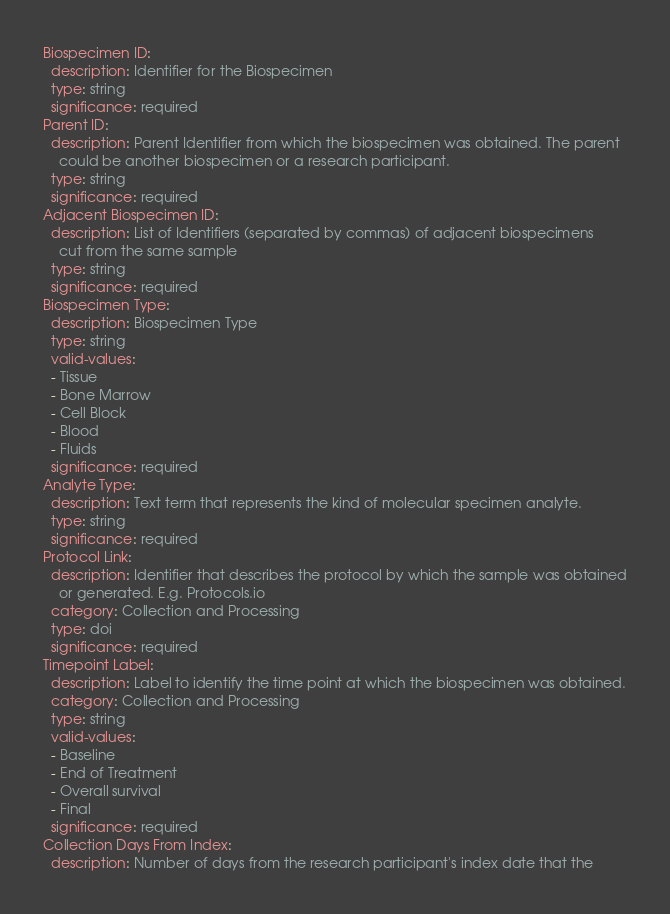Convert code to text. <code><loc_0><loc_0><loc_500><loc_500><_YAML_>Biospecimen ID:
  description: Identifier for the Biospecimen
  type: string
  significance: required
Parent ID:
  description: Parent Identifier from which the biospecimen was obtained. The parent
    could be another biospecimen or a research participant.
  type: string
  significance: required
Adjacent Biospecimen ID:
  description: List of Identifiers (separated by commas) of adjacent biospecimens
    cut from the same sample
  type: string
  significance: required
Biospecimen Type:
  description: Biospecimen Type
  type: string
  valid-values:
  - Tissue
  - Bone Marrow
  - Cell Block
  - Blood
  - Fluids
  significance: required
Analyte Type:
  description: Text term that represents the kind of molecular specimen analyte.
  type: string
  significance: required
Protocol Link:
  description: Identifier that describes the protocol by which the sample was obtained
    or generated. E.g. Protocols.io
  category: Collection and Processing
  type: doi
  significance: required
Timepoint Label:
  description: Label to identify the time point at which the biospecimen was obtained.
  category: Collection and Processing
  type: string
  valid-values:
  - Baseline
  - End of Treatment
  - Overall survival
  - Final
  significance: required
Collection Days From Index:
  description: Number of days from the research participant's index date that the</code> 